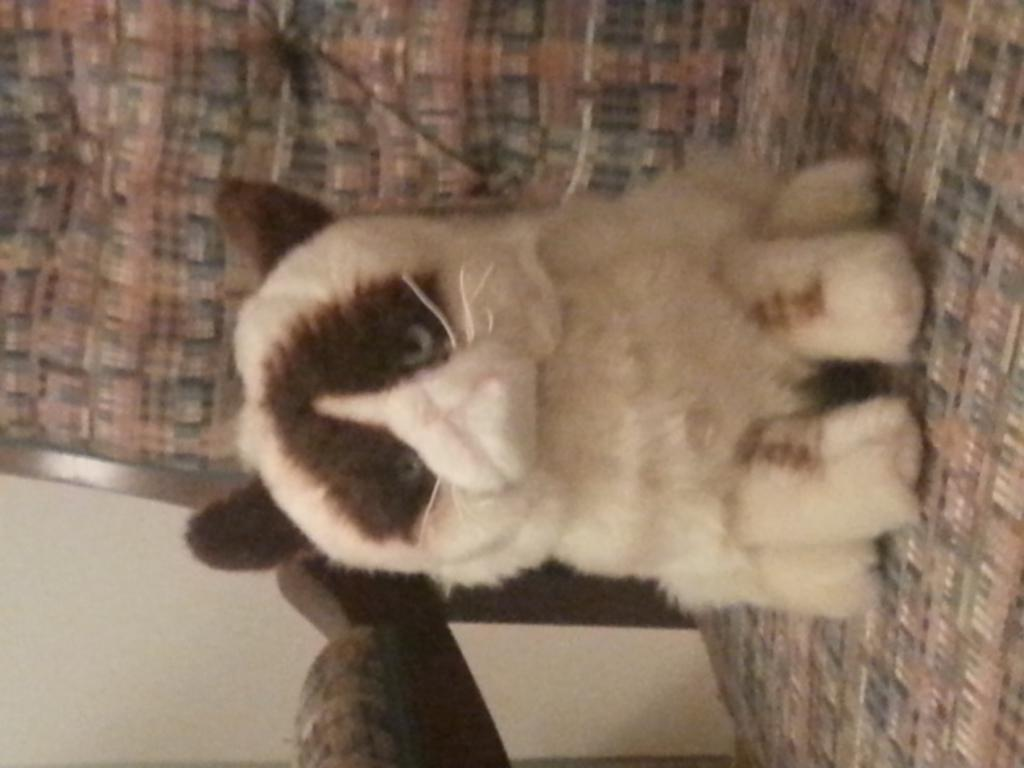Where was the image taken? The image was taken indoors. What can be seen at the left bottom of the image? There is a wall at the left bottom of the image. What is in the middle of the image? There is a chair in the middle of the image. What is on the chair? There is a cat on the chair. Can you see the cat smiling in the image? There is no indication of the cat's facial expression in the image, so it cannot be determined if the cat is smiling. 